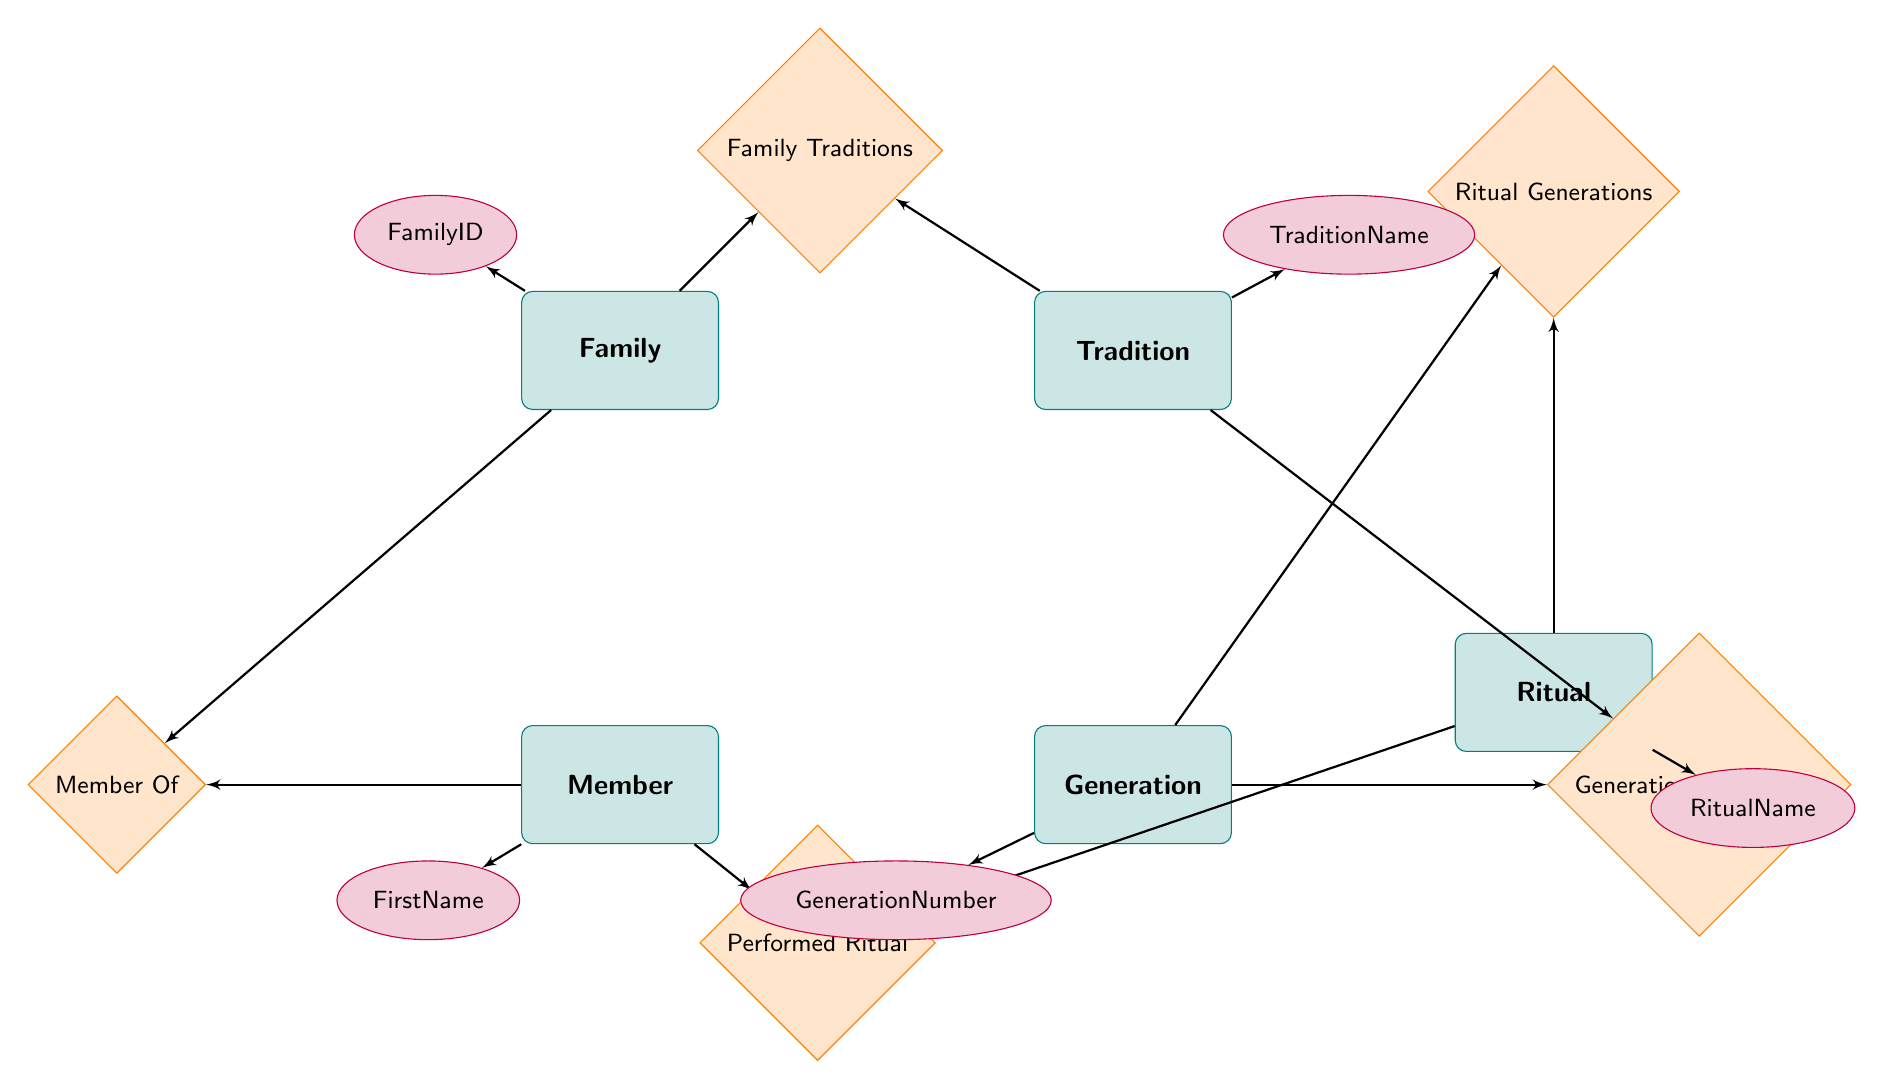What are the entities in the diagram? The entities are listed directly within the diagram; they are Family, Tradition, Member, Generation, and Ritual.
Answer: Family, Tradition, Member, Generation, Ritual How many relationships are present in the diagram? Counting the relationships displayed in the diagram reveals five distinct relationships: Family Traditions, Member Of, Generational Traditions, Performed Ritual, and Ritual Generations.
Answer: 5 What is the relationship type between Family and Tradition? The connection between Family and Tradition is depicted as a Many-to-Many relationship, indicating that one family can have multiple traditions, and one tradition can belong to multiple families.
Answer: Many-to-Many Which entity has the attribute 'FirstName'? By examining the attributes listed under each entity, it is clear that the Member entity includes the attribute 'FirstName' as part of its attributes.
Answer: Member What is the relationship between Generation and Ritual? Generation has a Many-to-Many relationship with Ritual, as indicated in the diagram. This means that any given generation can participate in multiple rituals, and those rituals can span multiple generations.
Answer: Many-to-Many How many attributes are associated with the Ritual entity? The attributes listed under the Ritual entity are RitualID, RitualName, DatePerformed, and Location. Thus, there are a total of four attributes associated with the Ritual entity in the diagram.
Answer: 4 What is the relationship type between Member and Family? The relationship depicted between Member and Family is a Many-to-One relationship, which indicates that multiple members can belong to a single family while each member is associated with only one family.
Answer: Many-to-One Which entity is connected to 'Generational Traditions'? Looking at the connections defined in the diagram, both Generation and Tradition entities are linked to the relationship called 'Generational Traditions', indicating both entities share this relationship.
Answer: Generation, Tradition What is the purpose of the 'Performed Ritual' relationship? The 'Performed Ritual' relationship signifies the connection between the Member entity and the Ritual entity, indicating that members can perform multiple rituals and that those rituals can be performed by multiple members as well.
Answer: To connect Members and Rituals How many nodes are there in total, including entities and relationships? By counting all entities (5) and all relationships (5) listed in the diagram, the total number of nodes equals ten nodes altogether.
Answer: 10 